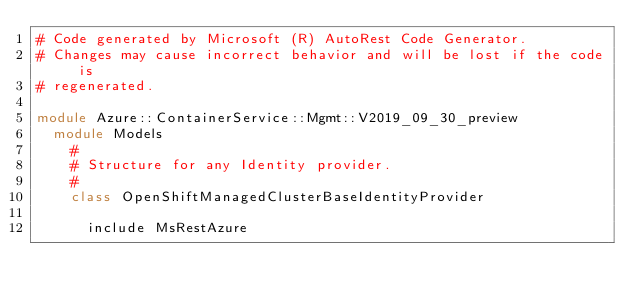Convert code to text. <code><loc_0><loc_0><loc_500><loc_500><_Ruby_># Code generated by Microsoft (R) AutoRest Code Generator.
# Changes may cause incorrect behavior and will be lost if the code is
# regenerated.

module Azure::ContainerService::Mgmt::V2019_09_30_preview
  module Models
    #
    # Structure for any Identity provider.
    #
    class OpenShiftManagedClusterBaseIdentityProvider

      include MsRestAzure
</code> 